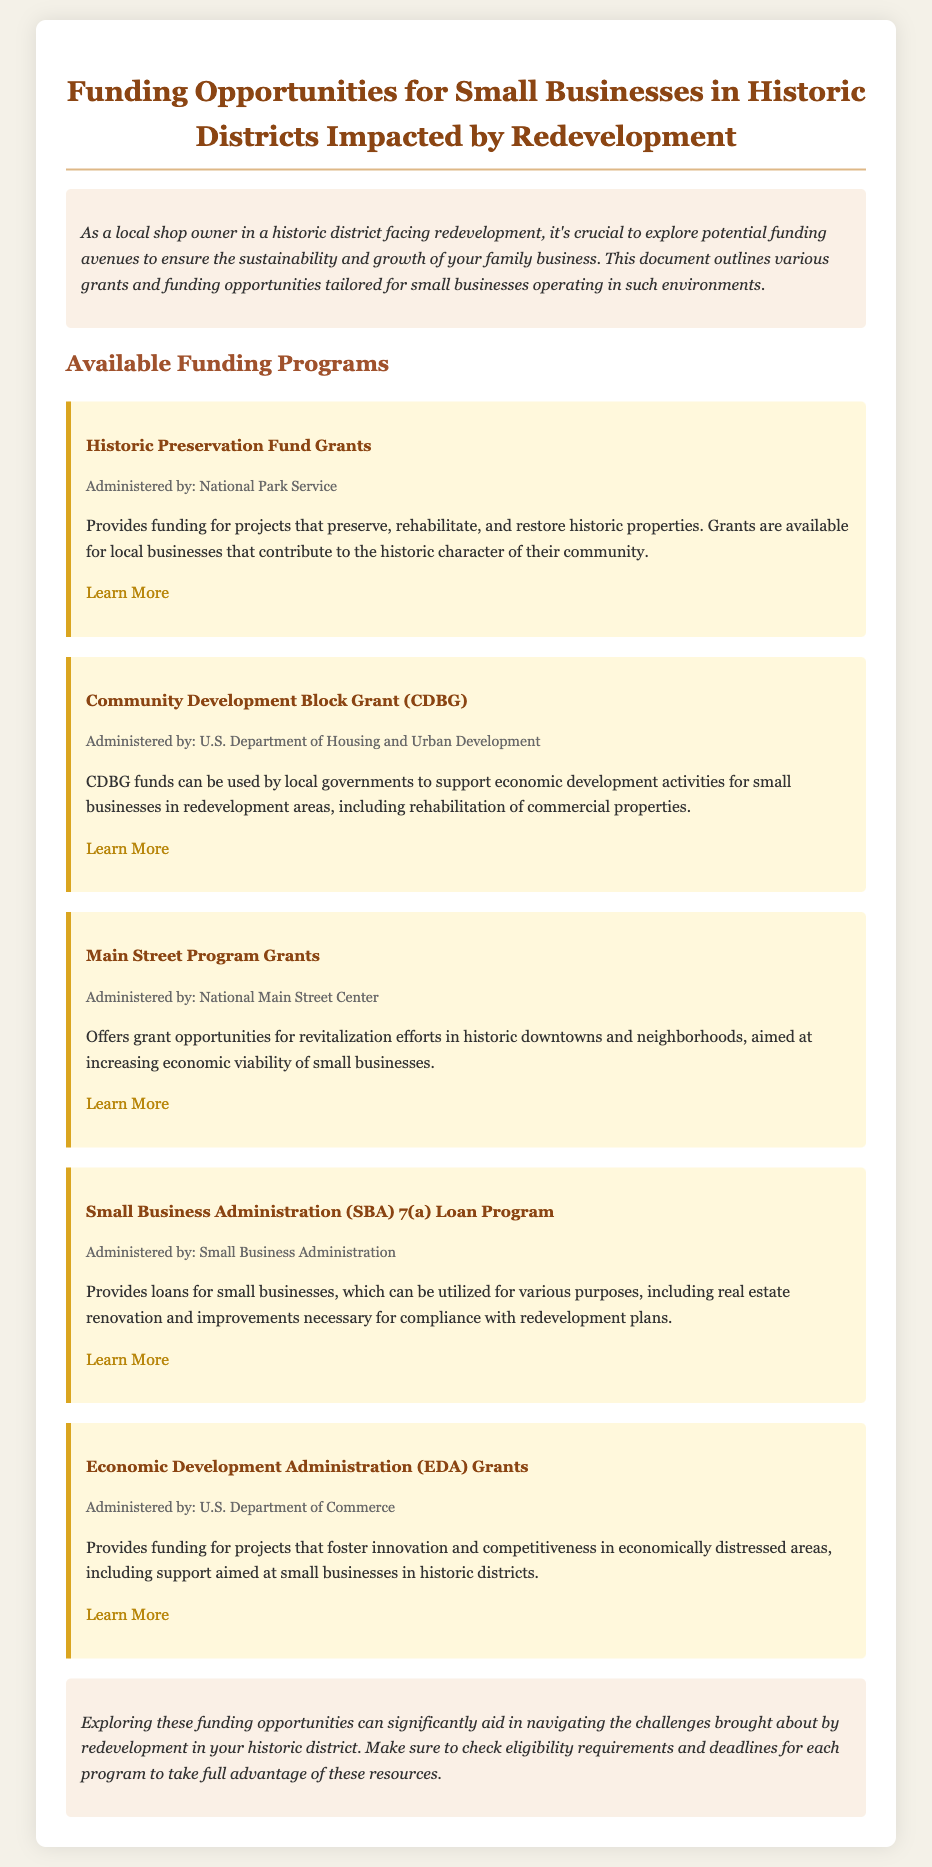What is the title of the document? The title of the document is prominently displayed at the top, summarizing the content.
Answer: Funding Opportunities for Small Businesses in Historic Districts Impacted by Redevelopment Who administers the Historic Preservation Fund Grants? The administration of the grant is specified under the program name section.
Answer: National Park Service What type of funding does the CDBG program provide? The funding type is described in the paragraph under the CDBG program section.
Answer: Economic development activities What is a purpose of the SBA 7(a) Loan Program? This purpose is stated clearly in the program description section.
Answer: Real estate renovation How many funding opportunities are listed in the document? The number of different funding opportunities is counted from the sections highlighted in the document.
Answer: Five What does EDA stand for? The abbreviation for EDA is explained in the title of that specific funding program.
Answer: Economic Development Administration What color scheme is primarily used in the document? The choice of colors used for the background, text, and headings indicates the overall aesthetic design.
Answer: Earth tones What is the target audience of the funding opportunities outlined? The target audience is specified at the beginning of the document in the introduction.
Answer: Small businesses in historic districts 